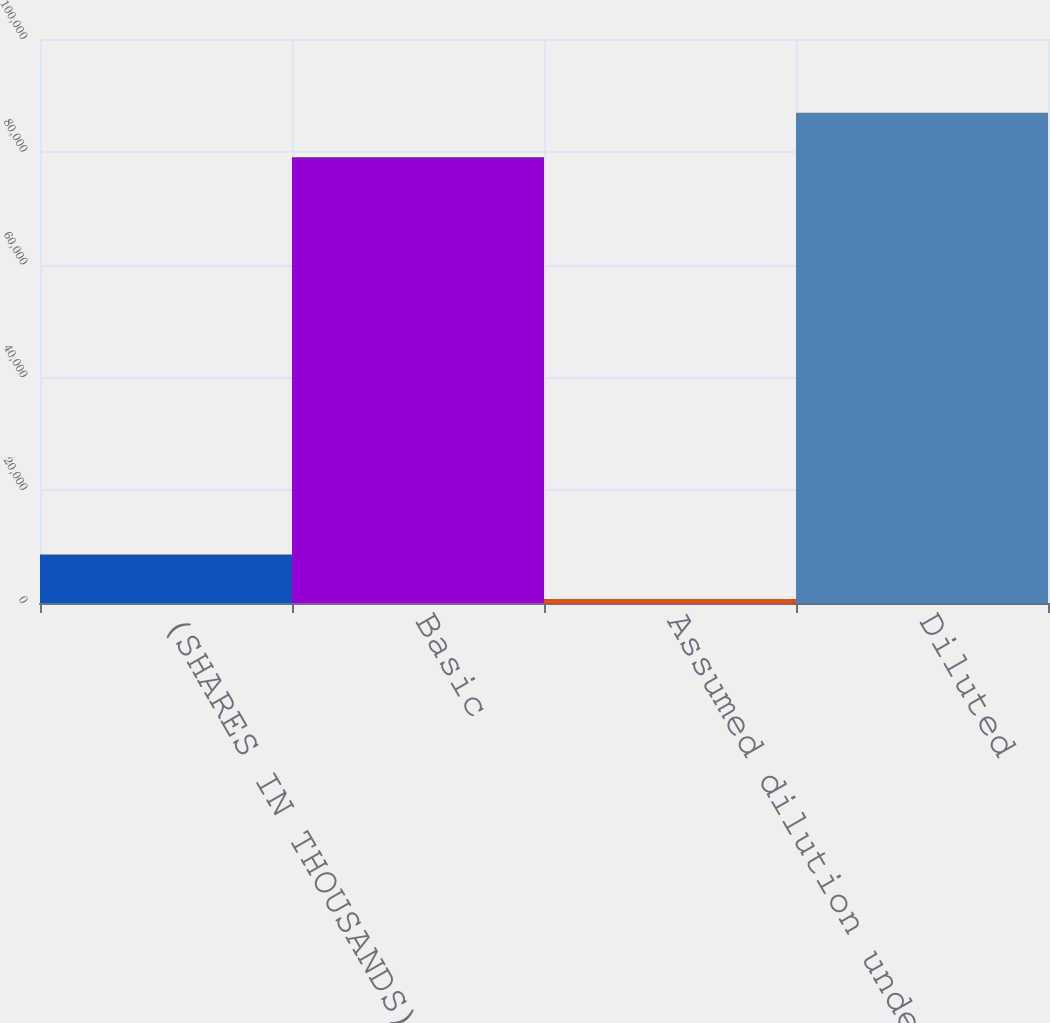Convert chart. <chart><loc_0><loc_0><loc_500><loc_500><bar_chart><fcel>(SHARES IN THOUSANDS)<fcel>Basic<fcel>Assumed dilution under stock<fcel>Diluted<nl><fcel>8594.2<fcel>79032<fcel>691<fcel>86935.2<nl></chart> 